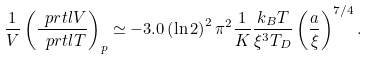<formula> <loc_0><loc_0><loc_500><loc_500>\frac { 1 } { V } \left ( \frac { \ p r t l V } { \ p r t l T } \right ) _ { p } \simeq - 3 . 0 \left ( \ln 2 \right ) ^ { 2 } \pi ^ { 2 } \frac { 1 } { K } \frac { k _ { B } T } { \xi ^ { 3 } T _ { D } } \left ( \frac { a } { \xi } \right ) ^ { 7 / 4 } .</formula> 